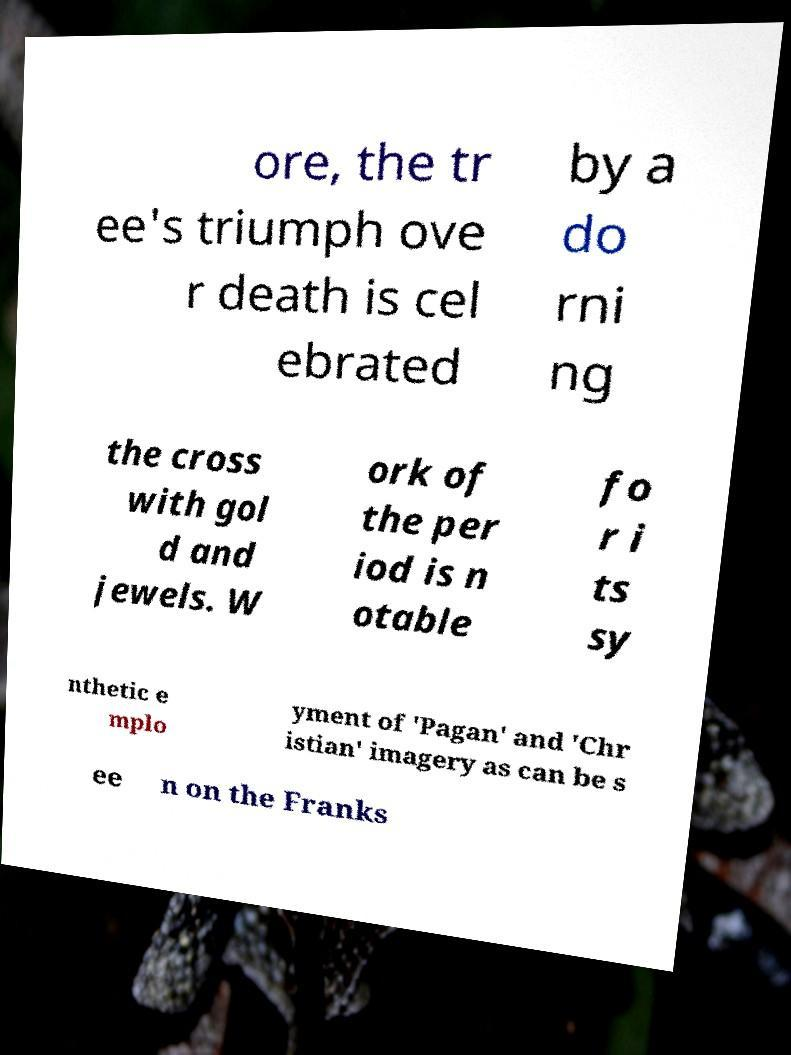Can you read and provide the text displayed in the image?This photo seems to have some interesting text. Can you extract and type it out for me? ore, the tr ee's triumph ove r death is cel ebrated by a do rni ng the cross with gol d and jewels. W ork of the per iod is n otable fo r i ts sy nthetic e mplo yment of 'Pagan' and 'Chr istian' imagery as can be s ee n on the Franks 